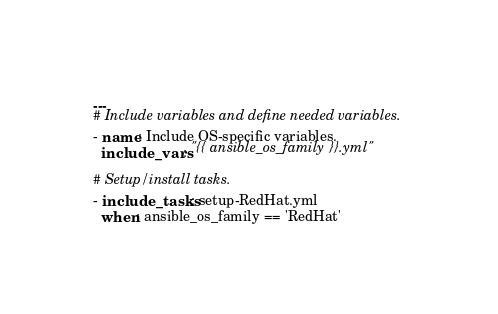<code> <loc_0><loc_0><loc_500><loc_500><_YAML_>---
# Include variables and define needed variables.
- name: Include OS-specific variables.
  include_vars: "{{ ansible_os_family }}.yml"

# Setup/install tasks.
- include_tasks: setup-RedHat.yml
  when: ansible_os_family == 'RedHat'
</code> 